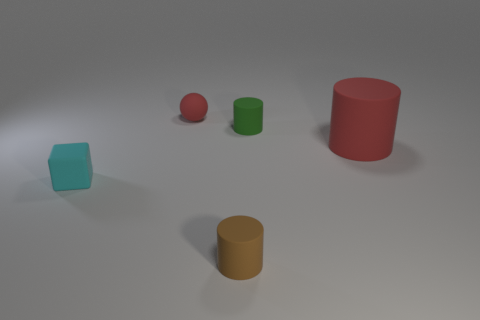What is the color of the tiny cylinder that is in front of the small cylinder behind the rubber cylinder that is in front of the large red rubber object?
Your answer should be very brief. Brown. Do the tiny cyan rubber thing and the green rubber thing have the same shape?
Your response must be concise. No. Are there an equal number of small red balls that are behind the small brown object and red cylinders?
Keep it short and to the point. Yes. What number of other things are the same material as the tiny cube?
Keep it short and to the point. 4. There is a red rubber object on the right side of the red ball; does it have the same size as the red rubber thing that is on the left side of the tiny brown matte cylinder?
Ensure brevity in your answer.  No. What number of objects are matte things that are on the left side of the small rubber ball or small matte things to the right of the cube?
Make the answer very short. 4. Is there any other thing that has the same shape as the cyan matte thing?
Make the answer very short. No. There is a matte thing behind the small green rubber cylinder; does it have the same color as the cylinder that is on the right side of the small green rubber object?
Your answer should be very brief. Yes. What number of rubber things are balls or tiny brown cylinders?
Keep it short and to the point. 2. Is there any other thing that has the same size as the red rubber cylinder?
Give a very brief answer. No. 